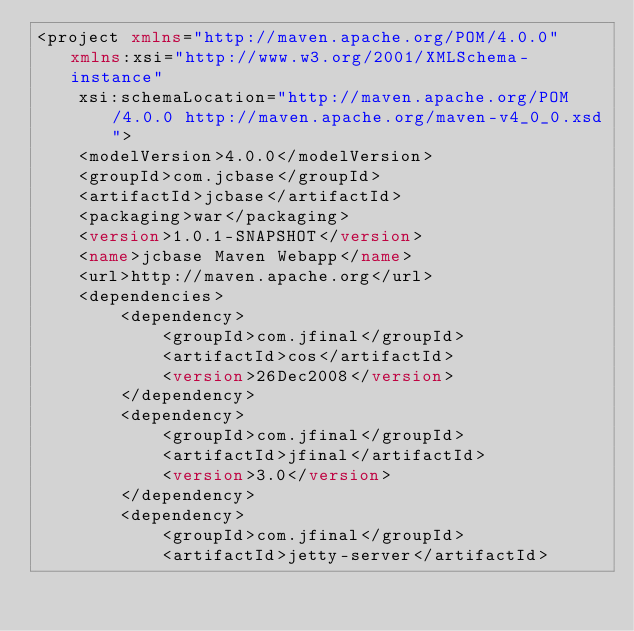Convert code to text. <code><loc_0><loc_0><loc_500><loc_500><_XML_><project xmlns="http://maven.apache.org/POM/4.0.0" xmlns:xsi="http://www.w3.org/2001/XMLSchema-instance"
	xsi:schemaLocation="http://maven.apache.org/POM/4.0.0 http://maven.apache.org/maven-v4_0_0.xsd">
	<modelVersion>4.0.0</modelVersion>
	<groupId>com.jcbase</groupId>
	<artifactId>jcbase</artifactId>
	<packaging>war</packaging>
	<version>1.0.1-SNAPSHOT</version>
	<name>jcbase Maven Webapp</name>
	<url>http://maven.apache.org</url>
	<dependencies>
		<dependency>
			<groupId>com.jfinal</groupId>
			<artifactId>cos</artifactId>
			<version>26Dec2008</version>
		</dependency>
		<dependency>
			<groupId>com.jfinal</groupId>
			<artifactId>jfinal</artifactId>
			<version>3.0</version>
		</dependency>
		<dependency>
			<groupId>com.jfinal</groupId>
			<artifactId>jetty-server</artifactId></code> 